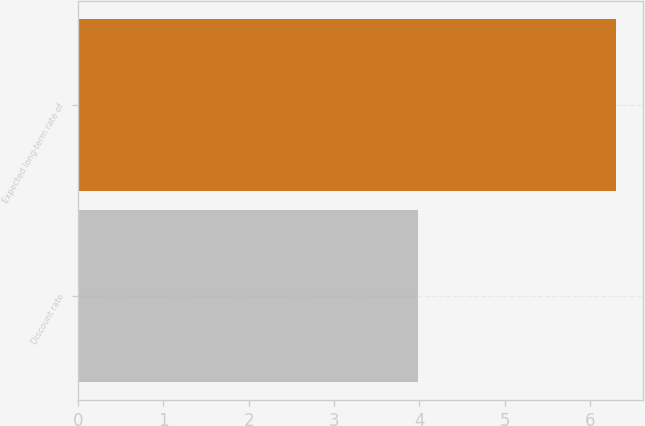Convert chart to OTSL. <chart><loc_0><loc_0><loc_500><loc_500><bar_chart><fcel>Discount rate<fcel>Expected long-term rate of<nl><fcel>3.98<fcel>6.3<nl></chart> 